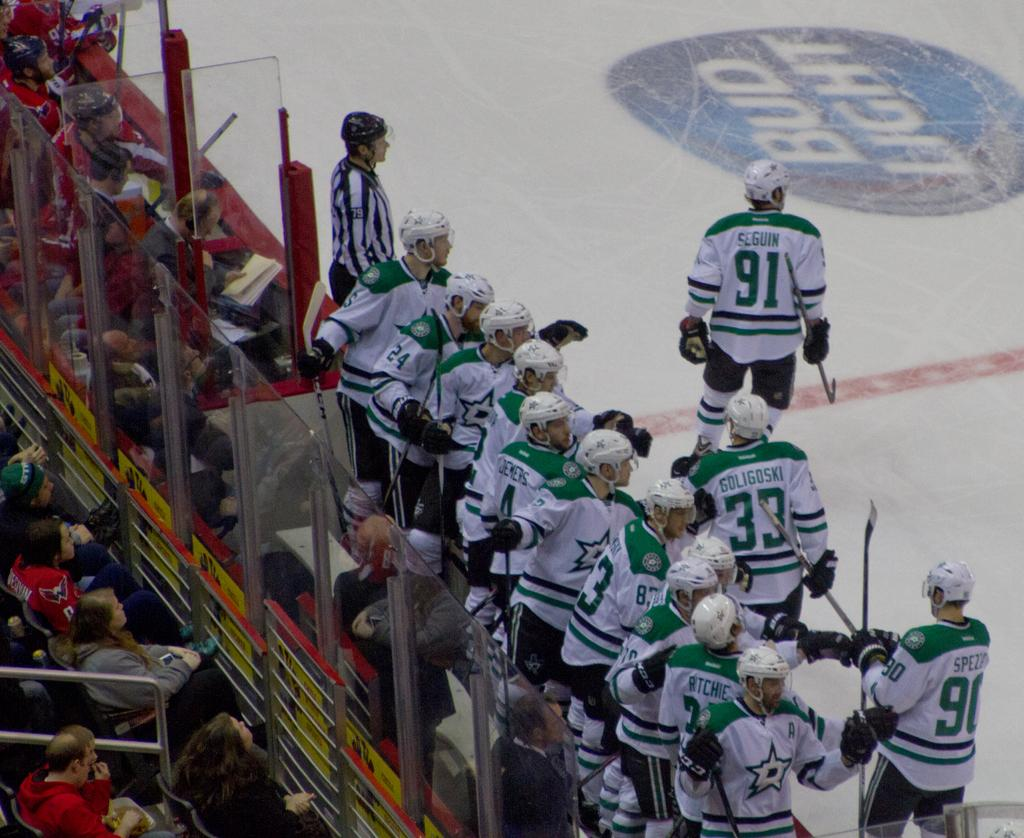<image>
Relay a brief, clear account of the picture shown. Ice hockey arena with hockey players and a Bud Light sign on the ice. 